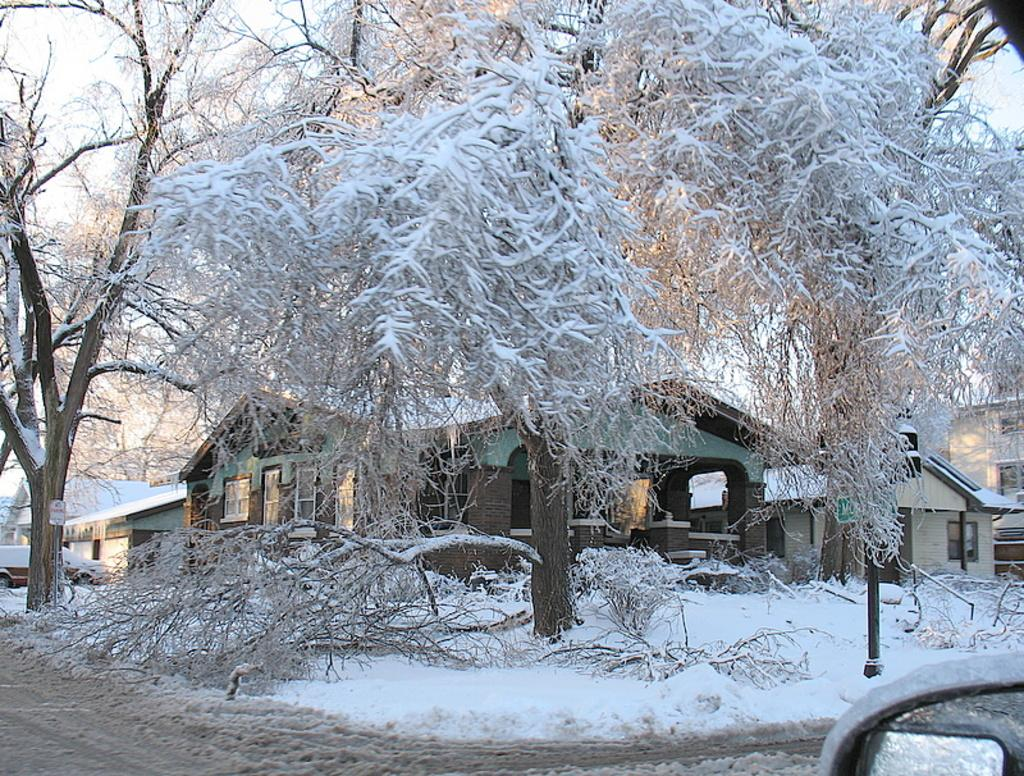What type of vegetation can be seen in the image? There are trees in the image. What type of structures are present in the image? There are houses in the image. What is the weather like in the image? There is snow visible in the image, indicating a cold or wintry weather. What is visible in the sky in the image? The sky is visible in the image. What is the income of the people living in the houses in the image? There is no information about the income of the people living in the houses in the image. Can you see a crack in the snow in the image? There is no mention of a crack in the snow in the image, and it is not visible in the provided facts. 